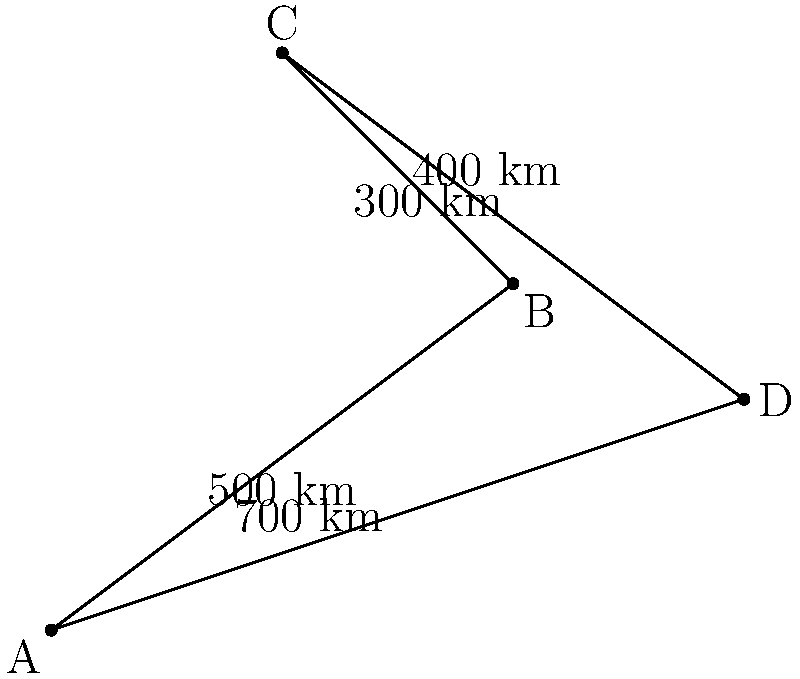As the CEO of your private jet booking app, you're optimizing a multi-city route for a high-profile client. The diagram shows four cities (A, B, C, and D) with distances between them. What is the shortest possible route that visits all four cities exactly once and returns to the starting point? To find the shortest route, we need to consider all possible permutations of the cities and calculate the total distance for each:

1. A-B-C-D-A: 500 + 400 + 300 + 700 = 1900 km
2. A-B-D-C-A: 500 + 200 + 300 + 400 = 1400 km
3. A-C-B-D-A: 400 + 400 + 200 + 700 = 1700 km
4. A-C-D-B-A: 400 + 300 + 200 + 500 = 1400 km
5. A-D-B-C-A: 700 + 200 + 400 + 400 = 1700 km
6. A-D-C-B-A: 700 + 300 + 400 + 500 = 1900 km

The shortest routes are A-B-D-C-A and A-C-D-B-A, both with a total distance of 1400 km.

To optimize fuel efficiency and reduce costs, we choose A-B-D-C-A as our answer, as it follows a more direct path with less backtracking.
Answer: A-B-D-C-A (1400 km) 